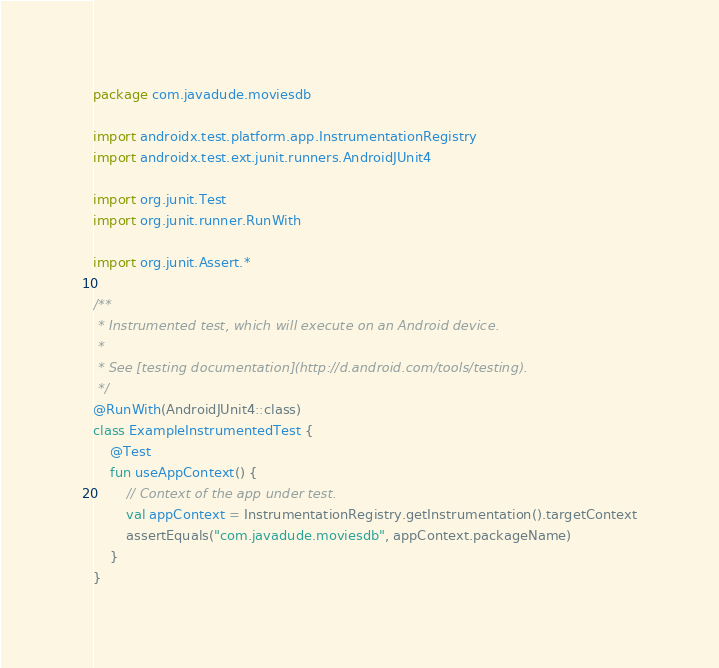Convert code to text. <code><loc_0><loc_0><loc_500><loc_500><_Kotlin_>package com.javadude.moviesdb

import androidx.test.platform.app.InstrumentationRegistry
import androidx.test.ext.junit.runners.AndroidJUnit4

import org.junit.Test
import org.junit.runner.RunWith

import org.junit.Assert.*

/**
 * Instrumented test, which will execute on an Android device.
 *
 * See [testing documentation](http://d.android.com/tools/testing).
 */
@RunWith(AndroidJUnit4::class)
class ExampleInstrumentedTest {
    @Test
    fun useAppContext() {
        // Context of the app under test.
        val appContext = InstrumentationRegistry.getInstrumentation().targetContext
        assertEquals("com.javadude.moviesdb", appContext.packageName)
    }
}
</code> 